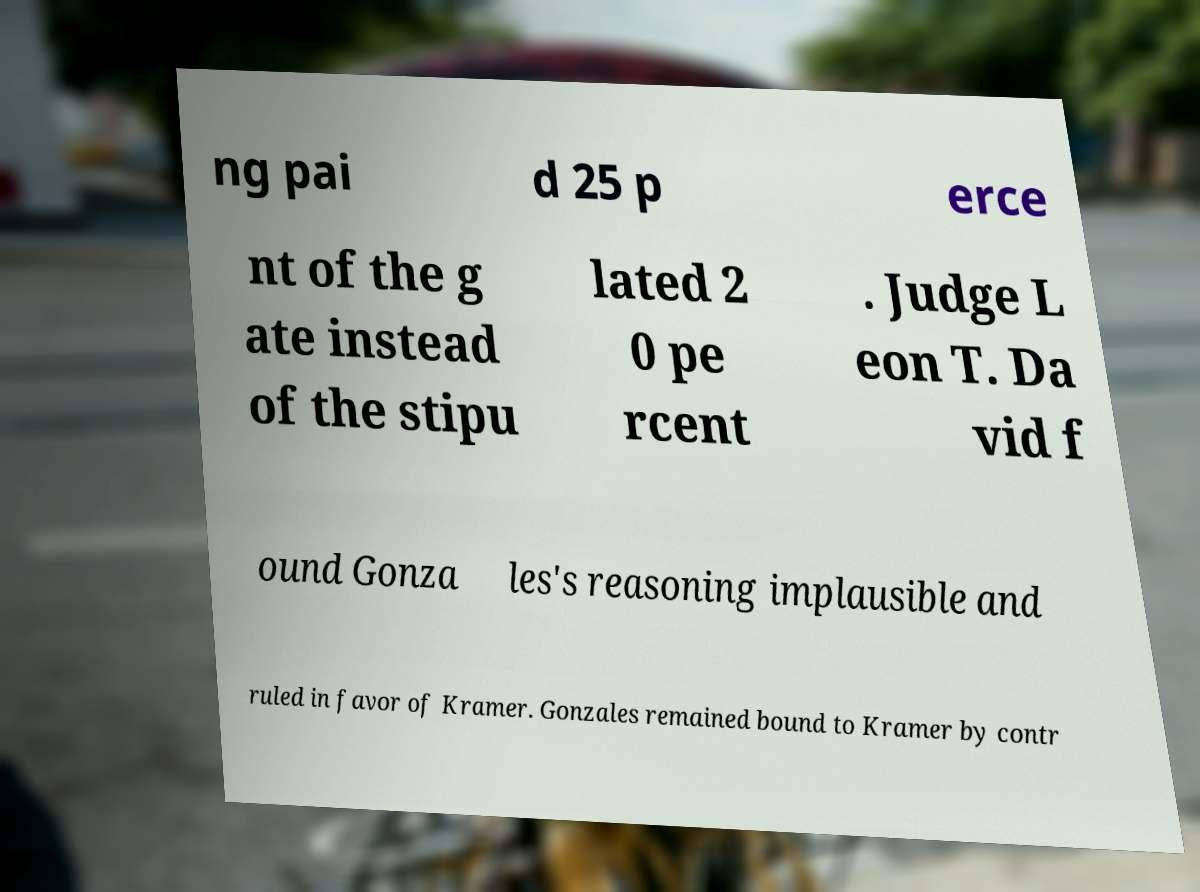Please identify and transcribe the text found in this image. ng pai d 25 p erce nt of the g ate instead of the stipu lated 2 0 pe rcent . Judge L eon T. Da vid f ound Gonza les's reasoning implausible and ruled in favor of Kramer. Gonzales remained bound to Kramer by contr 